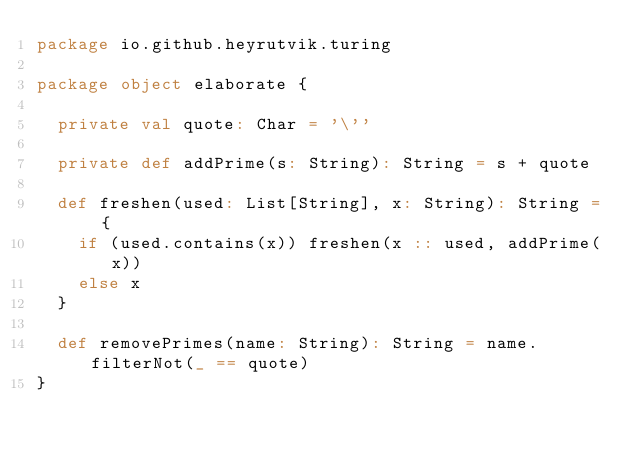Convert code to text. <code><loc_0><loc_0><loc_500><loc_500><_Scala_>package io.github.heyrutvik.turing

package object elaborate {

  private val quote: Char = '\''

  private def addPrime(s: String): String = s + quote

  def freshen(used: List[String], x: String): String = {
    if (used.contains(x)) freshen(x :: used, addPrime(x))
    else x
  }

  def removePrimes(name: String): String = name.filterNot(_ == quote)
}
</code> 